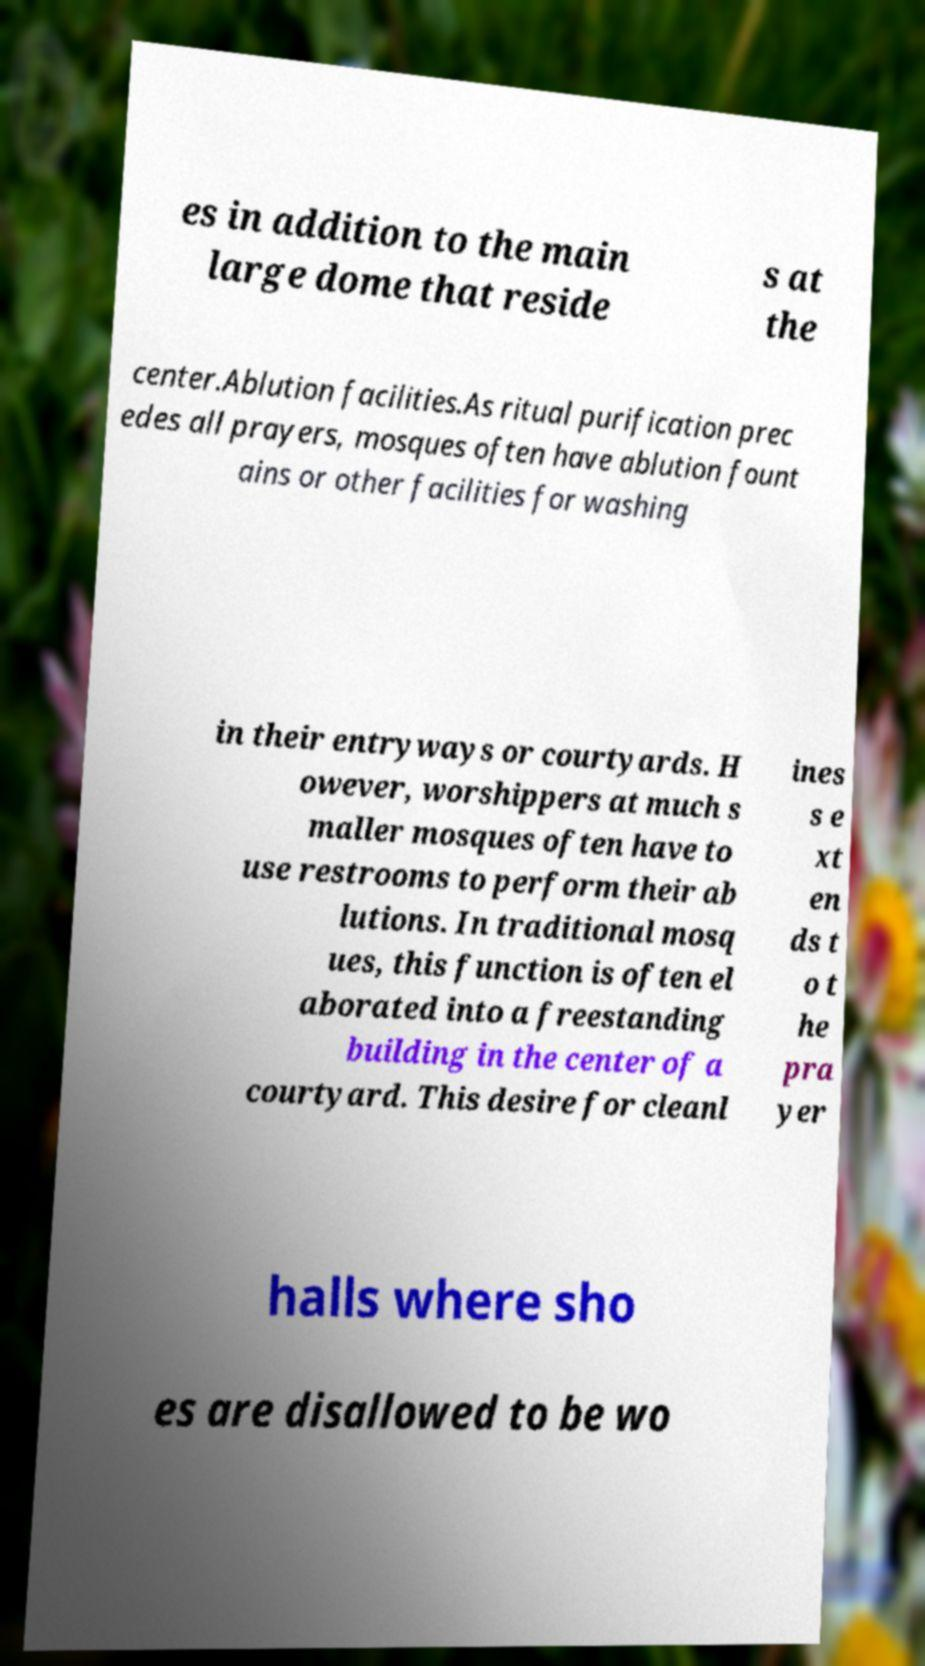Can you accurately transcribe the text from the provided image for me? es in addition to the main large dome that reside s at the center.Ablution facilities.As ritual purification prec edes all prayers, mosques often have ablution fount ains or other facilities for washing in their entryways or courtyards. H owever, worshippers at much s maller mosques often have to use restrooms to perform their ab lutions. In traditional mosq ues, this function is often el aborated into a freestanding building in the center of a courtyard. This desire for cleanl ines s e xt en ds t o t he pra yer halls where sho es are disallowed to be wo 